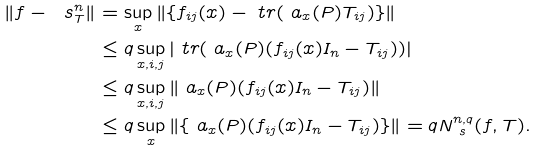Convert formula to latex. <formula><loc_0><loc_0><loc_500><loc_500>\| f - \ s _ { T } ^ { n } \| & = \sup _ { x } \| \{ f _ { i j } ( x ) - \ t r ( \ a _ { x } ( P ) T _ { i j } ) \} \| \\ & \leq q \sup _ { x , i , j } | \ t r ( \ a _ { x } ( P ) ( f _ { i j } ( x ) I _ { n } - T _ { i j } ) ) | \\ & \leq q \sup _ { x , i , j } \| \ a _ { x } ( P ) ( f _ { i j } ( x ) I _ { n } - T _ { i j } ) \| \\ & \leq q \sup _ { x } \| \{ \ a _ { x } ( P ) ( f _ { i j } ( x ) I _ { n } - T _ { i j } ) \} \| = q N _ { \ s } ^ { n , q } ( f , T ) .</formula> 